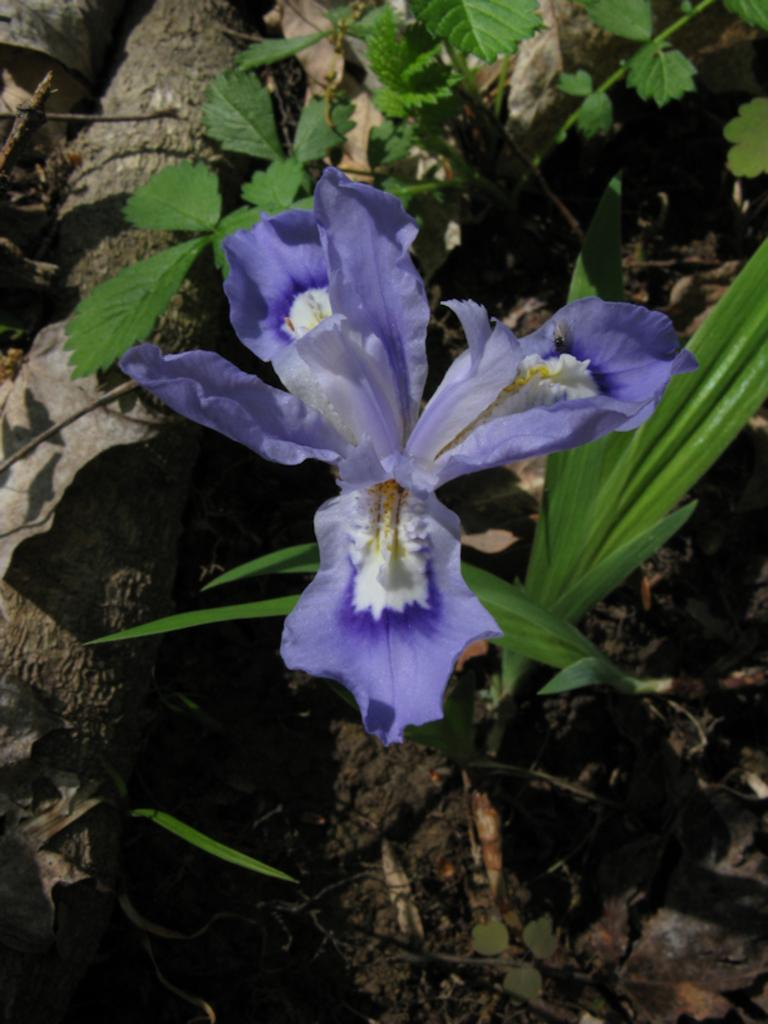What type of living organisms can be seen in the image? Plants can be seen in the image. What specific feature of the plants is visible? The plants have flowers. What colors are the flowers in the image? The flowers are white and purple in color. What type of crate is used to store the committee's business in the image? There is no crate, committee, or business present in the image; it only features plants with white and purple flowers. 